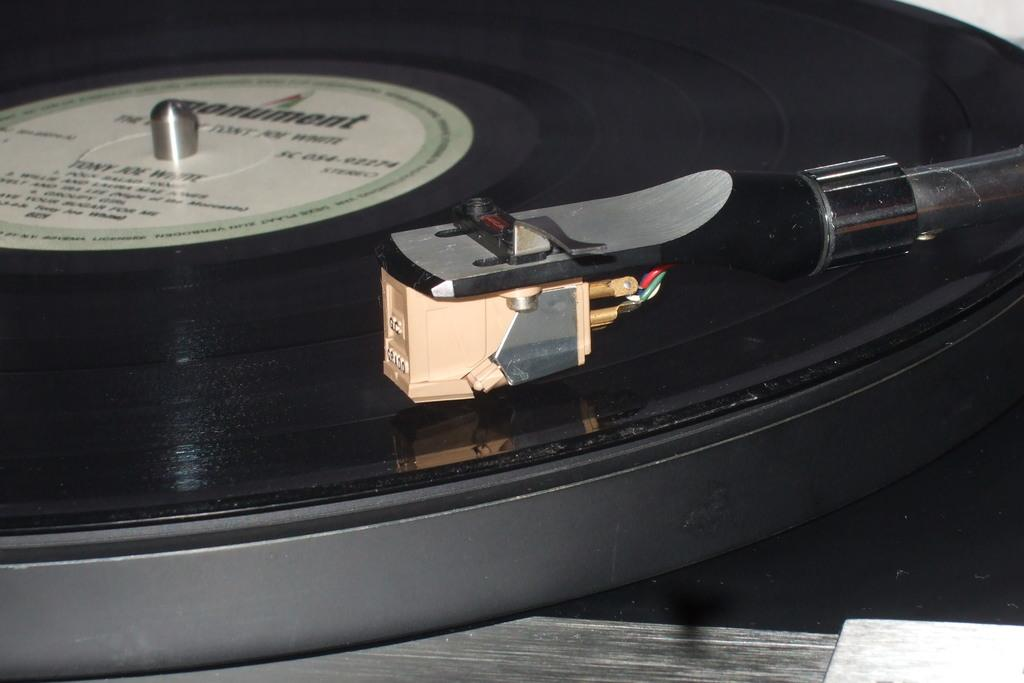What is the main object in the image? There is a device in the image. Where is the device located? The device is on a platform. What type of beef is being cooked on the device in the image? There is no beef or cooking activity present in the image; it only features a device on a platform. 